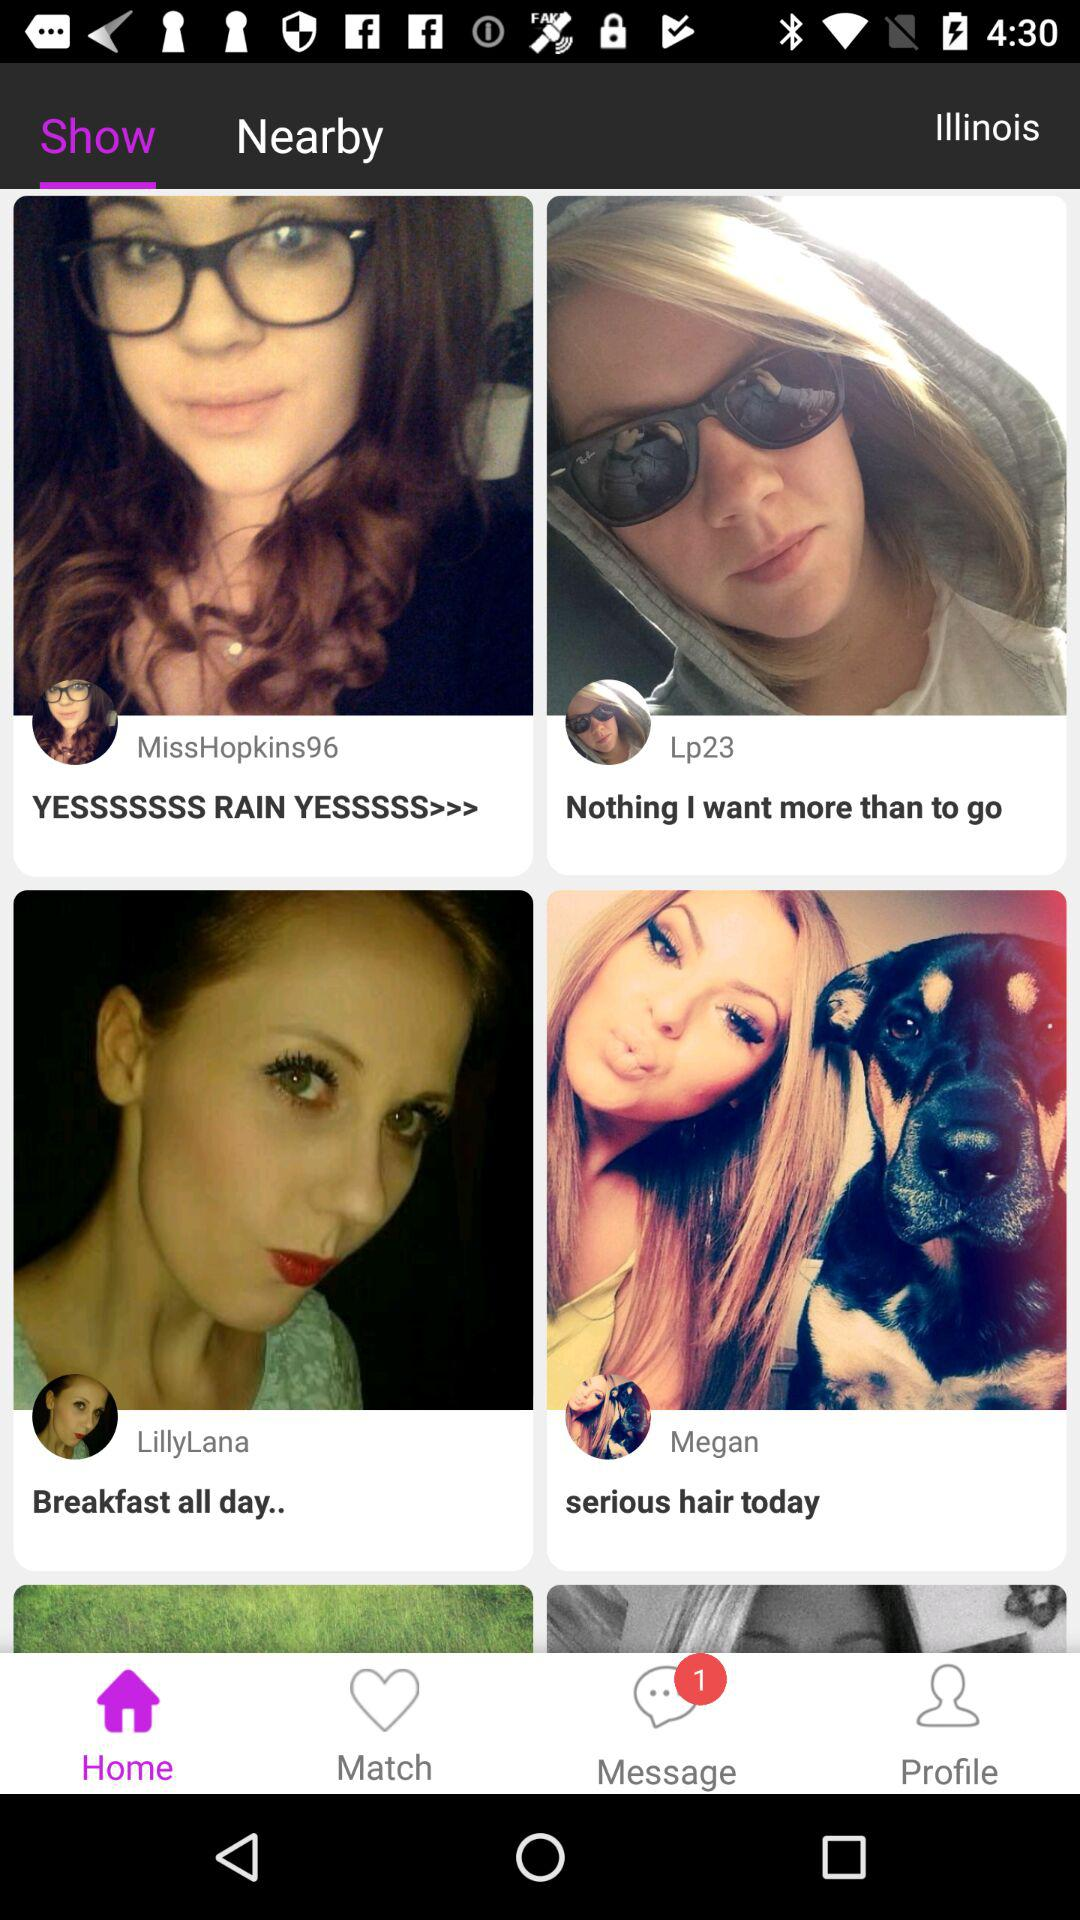What is the caption of Lp23? The caption is "Nothing I want more than to go". 